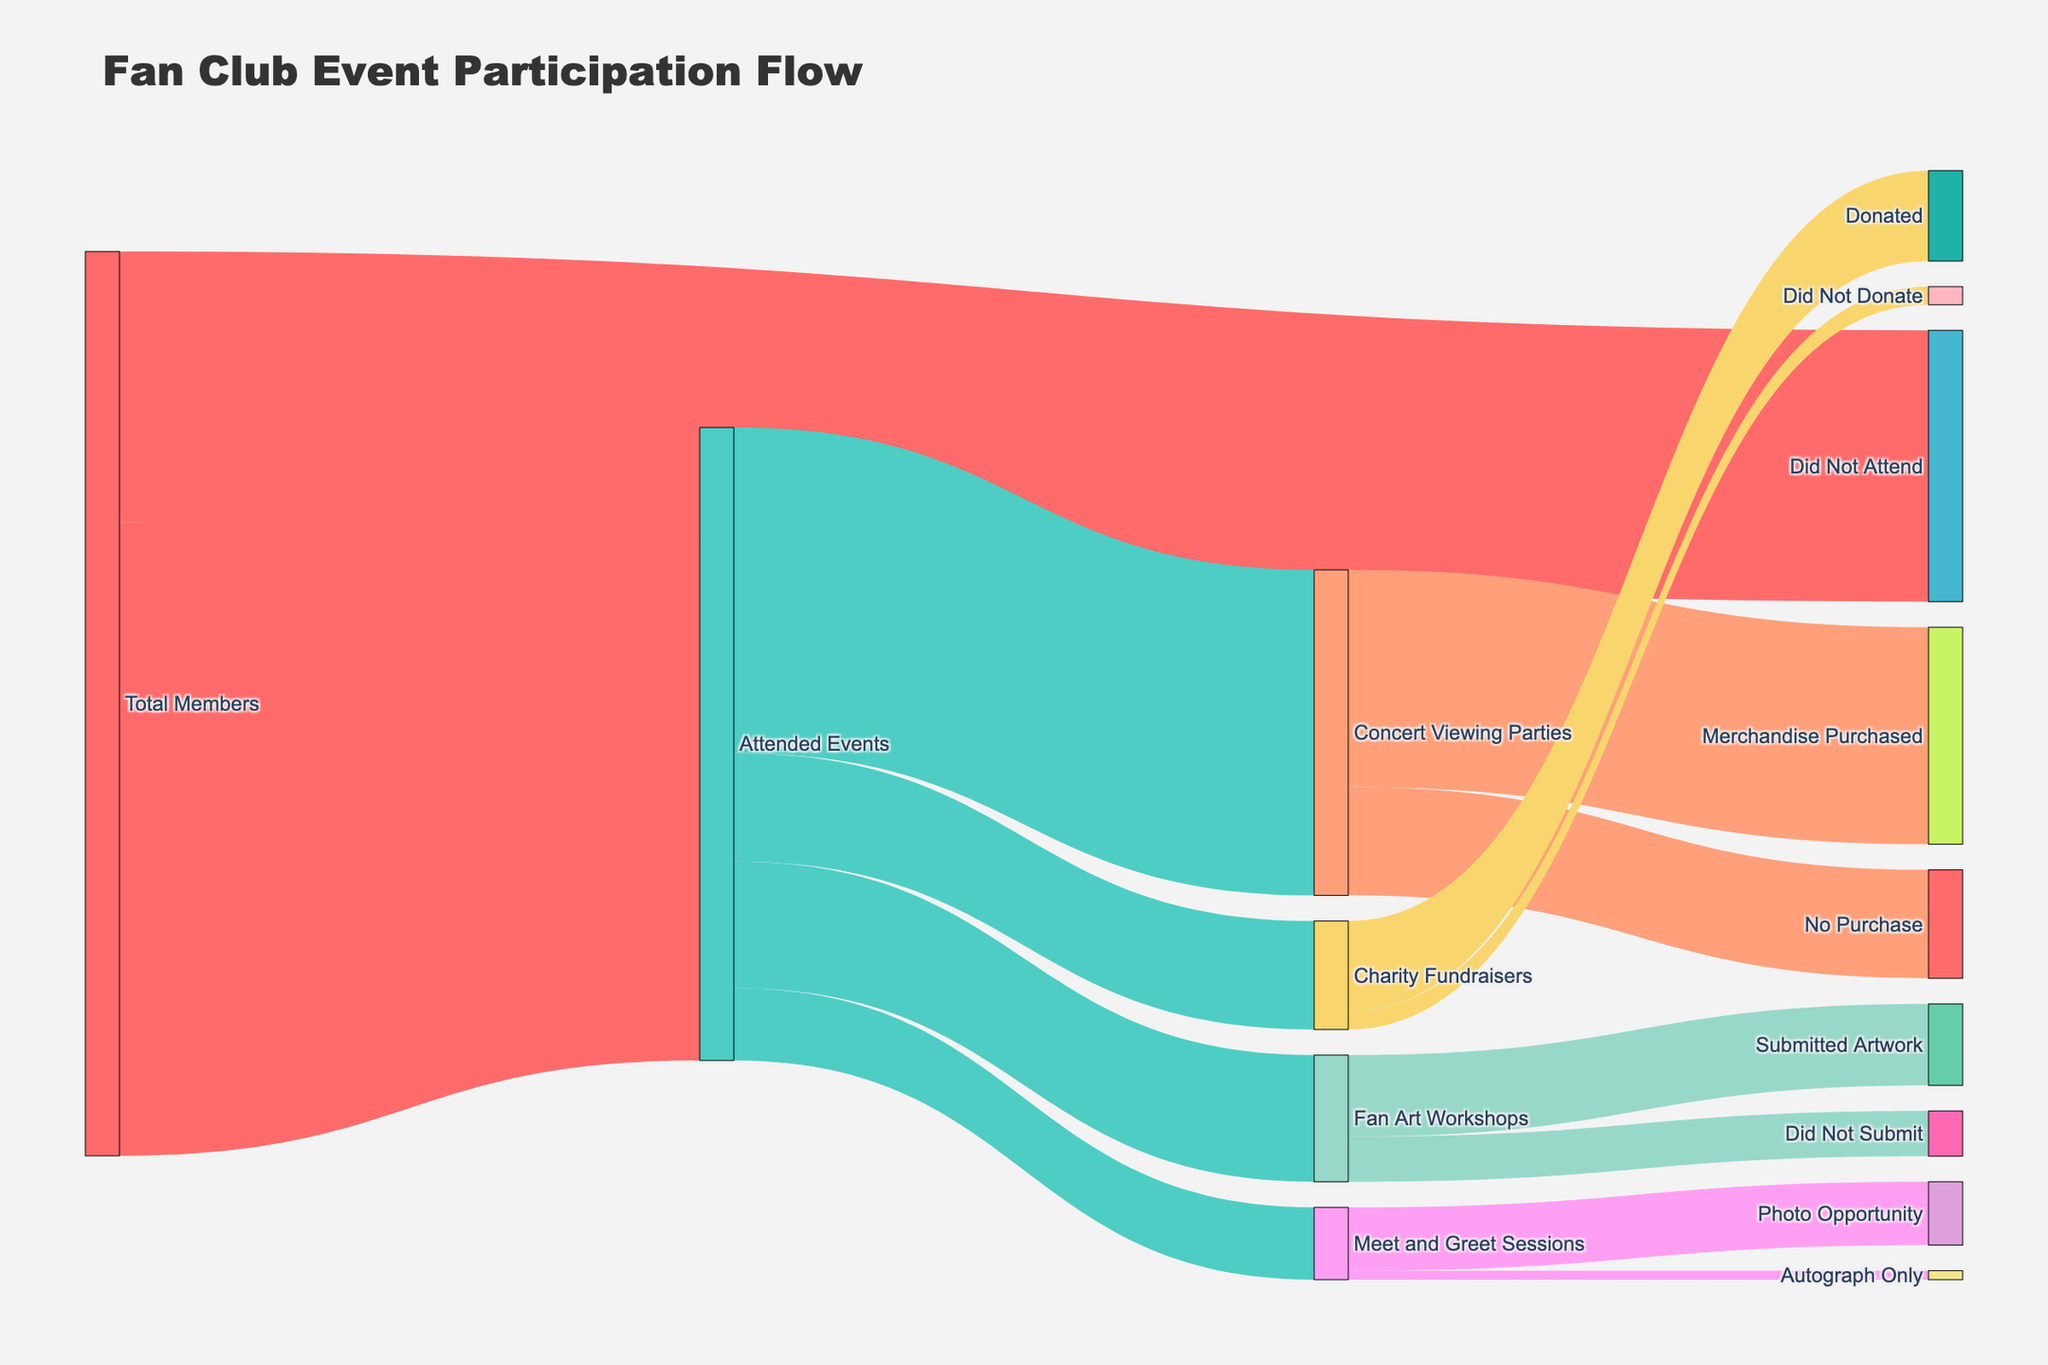What is the title of the Sankey diagram? The title of the Sankey diagram is typically displayed at the top of the figure. It summarizes the main topic the figure is about.
Answer: Fan Club Event Participation Flow How many members attended events compared to those who did not? To find out, look for the values flowing from "Total Members" to "Attended Events" and "Did Not Attend."
Answer: 3500 attended, 1500 did not How many members attended Concert Viewing Parties? Look at the flow from "Attended Events" to "Concert Viewing Parties." The value next to this flow represents the number of members who attended the viewing parties.
Answer: 1800 How many people attended more than one type of event? This is a bit tricky. We need to infer by looking at the sum of attendees at each event type ("Concert Viewing Parties", "Fan Art Workshops", "Charity Fundraisers", "Meet and Greet Sessions") and compare it to the total attendees "Attended Events." Since the total is 3500 and the sum of individual event types is 1800 + 700 + 600 + 400 = 3500, it suggests no overlap.
Answer: 0 Which fan club activity had the highest attendance? Compare the values connected between "Attended Events" and the individual activities.
Answer: Concert Viewing Parties What percentage of members who attended Concert Viewing Parties also purchased merchandise? To calculate the percentage, divide the number who purchased merchandise (1200) by those who attended the Viewing Parties (1800) and multiply by 100.
Answer: 66.67% How many members attended both Concert Viewing Parties and Fan Art Workshops? Since this is a Sankey Diagram, it typically doesn’t show overlaps directly, but since each activity is a branch of "Attended Events," we assume each flow is mutually exclusive. Thus, zero members attended both.
Answer: 0 What fraction of attendees participated in Fan Art Workshops but did not submit artwork? Divide the number who did not submit artwork (250) by those who attended the Fan Art Workshops (700).
Answer: 250/700 or approximately 0.357 Which activity had the least engagement in terms of members’ follow-up actions? Compare "No Purchase," "Did Not Submit," "Did Not Donate," and "Autograph Only" to determine the activity with the highest no-action value.
Answer: Did Not Submit (250) Who had a photo opportunity at Meet and Greet Sessions? Look at the flow from "Meet and Greet Sessions" to "Photo Opportunity" to find this value.
Answer: 350 